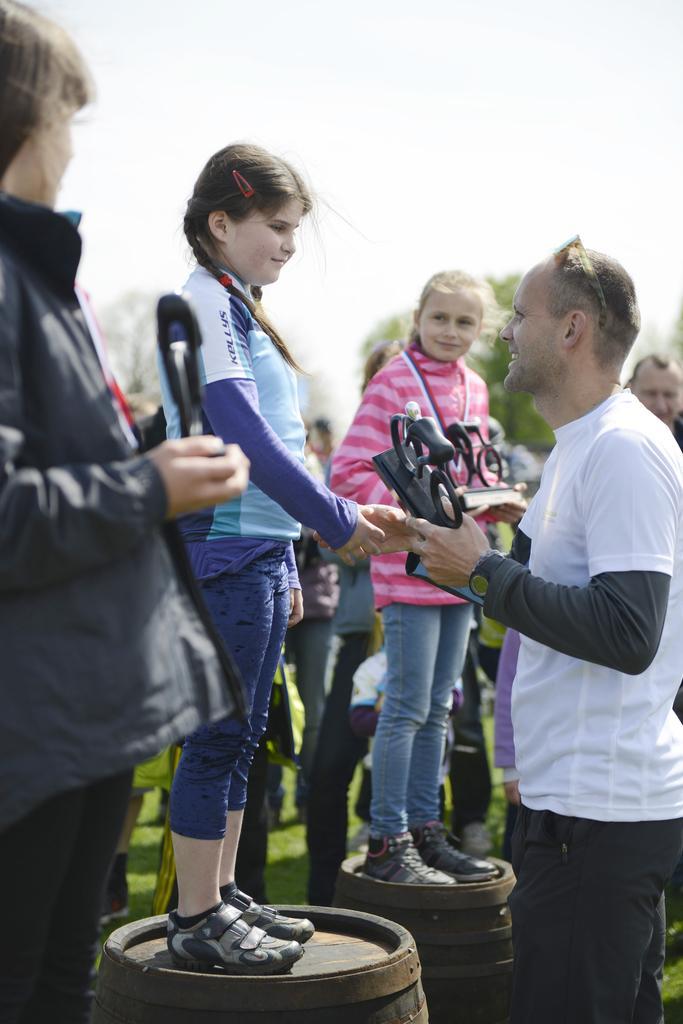Could you give a brief overview of what you see in this image? In this image I can see people among them some are standing on barrels. In the background I can see the sky. Here I can see a man is holding something in the hand. 